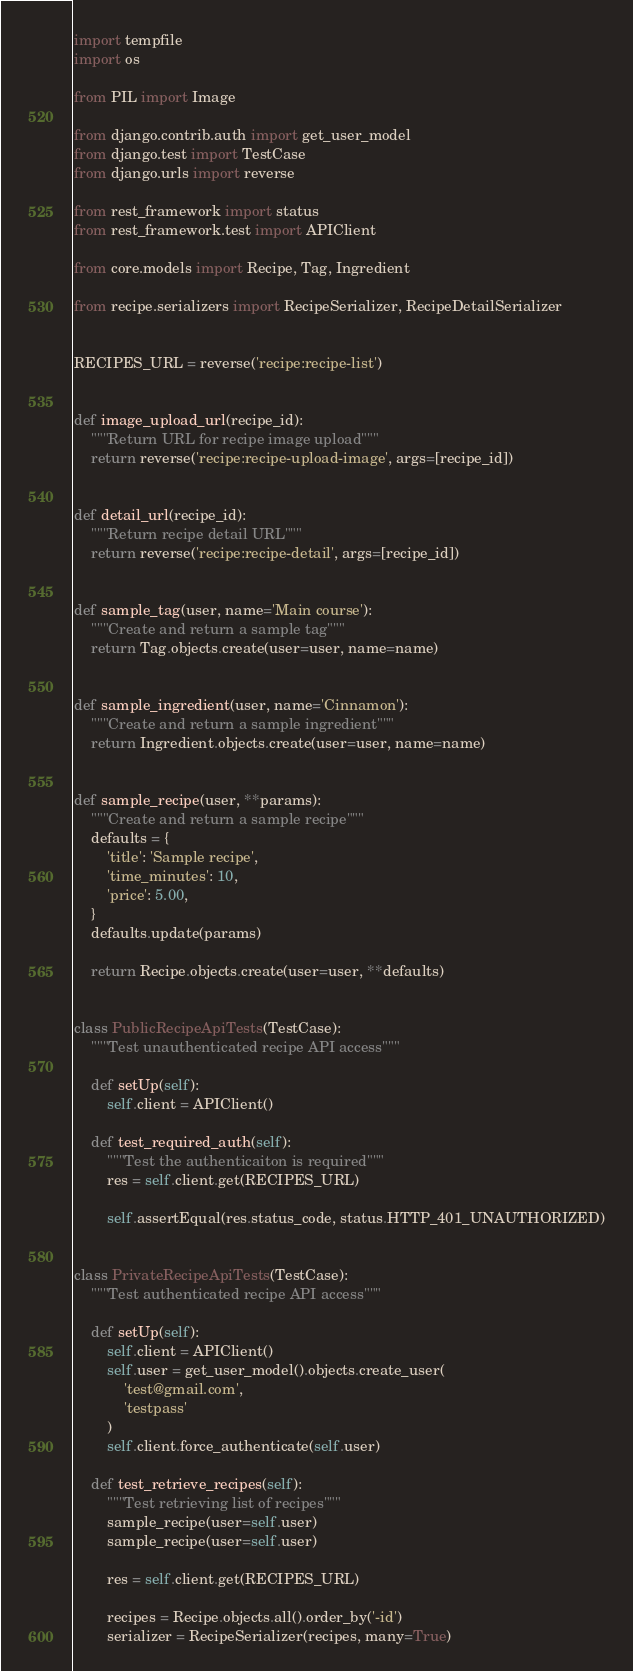<code> <loc_0><loc_0><loc_500><loc_500><_Python_>import tempfile
import os

from PIL import Image

from django.contrib.auth import get_user_model
from django.test import TestCase
from django.urls import reverse

from rest_framework import status
from rest_framework.test import APIClient

from core.models import Recipe, Tag, Ingredient

from recipe.serializers import RecipeSerializer, RecipeDetailSerializer


RECIPES_URL = reverse('recipe:recipe-list')


def image_upload_url(recipe_id):
    """Return URL for recipe image upload"""
    return reverse('recipe:recipe-upload-image', args=[recipe_id])


def detail_url(recipe_id):
    """Return recipe detail URL"""
    return reverse('recipe:recipe-detail', args=[recipe_id])


def sample_tag(user, name='Main course'):
    """Create and return a sample tag"""
    return Tag.objects.create(user=user, name=name)


def sample_ingredient(user, name='Cinnamon'):
    """Create and return a sample ingredient"""
    return Ingredient.objects.create(user=user, name=name)


def sample_recipe(user, **params):
    """Create and return a sample recipe"""
    defaults = {
        'title': 'Sample recipe',
        'time_minutes': 10,
        'price': 5.00,
    }
    defaults.update(params)

    return Recipe.objects.create(user=user, **defaults)


class PublicRecipeApiTests(TestCase):
    """Test unauthenticated recipe API access"""

    def setUp(self):
        self.client = APIClient()

    def test_required_auth(self):
        """Test the authenticaiton is required"""
        res = self.client.get(RECIPES_URL)

        self.assertEqual(res.status_code, status.HTTP_401_UNAUTHORIZED)


class PrivateRecipeApiTests(TestCase):
    """Test authenticated recipe API access"""

    def setUp(self):
        self.client = APIClient()
        self.user = get_user_model().objects.create_user(
            'test@gmail.com',
            'testpass'
        )
        self.client.force_authenticate(self.user)

    def test_retrieve_recipes(self):
        """Test retrieving list of recipes"""
        sample_recipe(user=self.user)
        sample_recipe(user=self.user)

        res = self.client.get(RECIPES_URL)

        recipes = Recipe.objects.all().order_by('-id')
        serializer = RecipeSerializer(recipes, many=True)</code> 